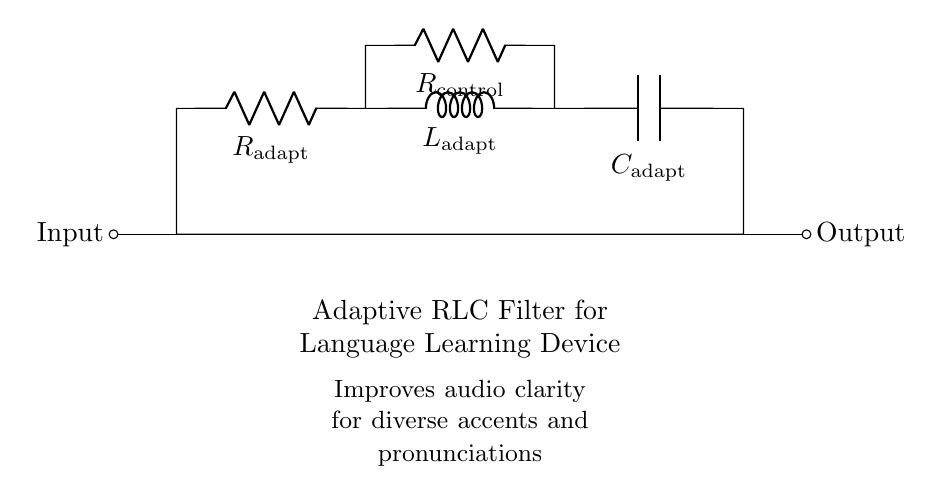What are the components in the circuit? The circuit consists of a resistor, an inductor, and a capacitor, as indicated by the labels R, L, and C.
Answer: Resistor, Inductor, Capacitor What is the purpose of the adaptive filter? The purpose, as noted in the description, is to improve audio clarity for diverse accents and pronunciations in a language learning device.
Answer: Improve audio clarity What is the control component labeled as? The component labeled in the circuit as R control is specifically designed to control the adaptive behavior of the filter.
Answer: R control What is the position of the input and output terminals? The input terminal is located on the left side, and the output terminal is on the right side of the circuit diagram.
Answer: Left and Right Why is the R adapt utilized in this design? R adapt is part of the adaptive filter that adjusts the resistance based on the input signal to optimize performance for varying audio conditions. This enhances the circuit’s adaptability.
Answer: To optimize performance How does the combination of R, L, and C affect the filter response? The combination of a resistor, inductor, and capacitor determines the filter's characteristics, such as its cutoff frequency, bandwidth, and resonance behavior, which affect how it interprets sound signals.
Answer: Determines filter characteristics What is the effect of using adaptive components in the filter? Using adaptive components allows the filter to automatically adjust its settings based on input characteristics, enhancing its ability to process diverse audio signals effectively.
Answer: Enhances audio processing 